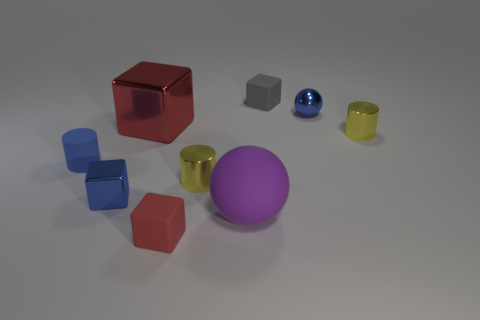There is a gray thing; are there any tiny blue metal cubes behind it?
Provide a short and direct response. No. There is a blue object that is the same shape as the big purple matte object; what size is it?
Your answer should be compact. Small. Is there anything else that is the same size as the blue sphere?
Offer a terse response. Yes. Does the small red rubber object have the same shape as the large red metal thing?
Ensure brevity in your answer.  Yes. What is the size of the cylinder that is to the right of the cube to the right of the red rubber object?
Your response must be concise. Small. There is another small matte thing that is the same shape as the tiny red thing; what color is it?
Offer a terse response. Gray. How many tiny things are the same color as the tiny matte cylinder?
Offer a terse response. 2. The red metallic cube is what size?
Your response must be concise. Large. Does the blue shiny block have the same size as the red matte block?
Ensure brevity in your answer.  Yes. What is the color of the object that is in front of the tiny blue rubber cylinder and on the left side of the big red block?
Offer a very short reply. Blue. 